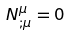<formula> <loc_0><loc_0><loc_500><loc_500>N _ { ; \mu } ^ { \mu } = 0</formula> 